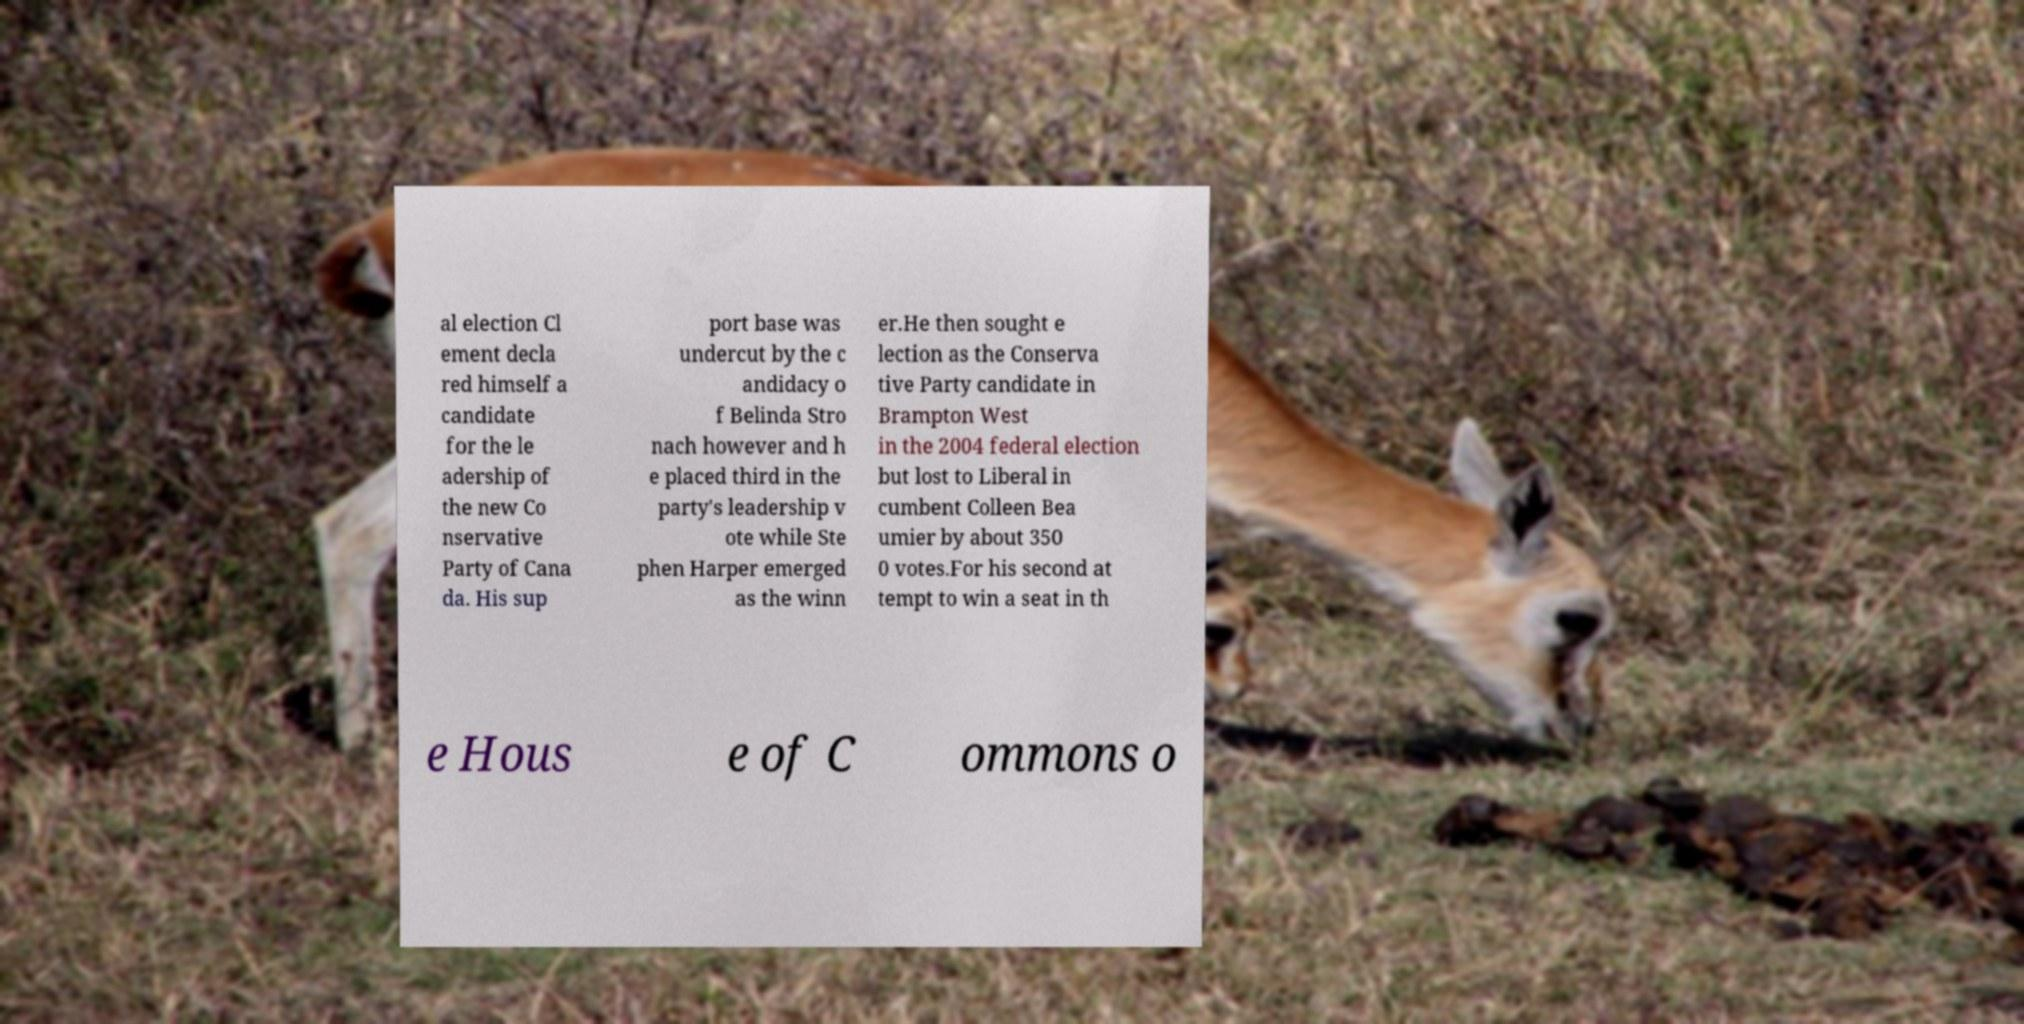I need the written content from this picture converted into text. Can you do that? al election Cl ement decla red himself a candidate for the le adership of the new Co nservative Party of Cana da. His sup port base was undercut by the c andidacy o f Belinda Stro nach however and h e placed third in the party's leadership v ote while Ste phen Harper emerged as the winn er.He then sought e lection as the Conserva tive Party candidate in Brampton West in the 2004 federal election but lost to Liberal in cumbent Colleen Bea umier by about 350 0 votes.For his second at tempt to win a seat in th e Hous e of C ommons o 